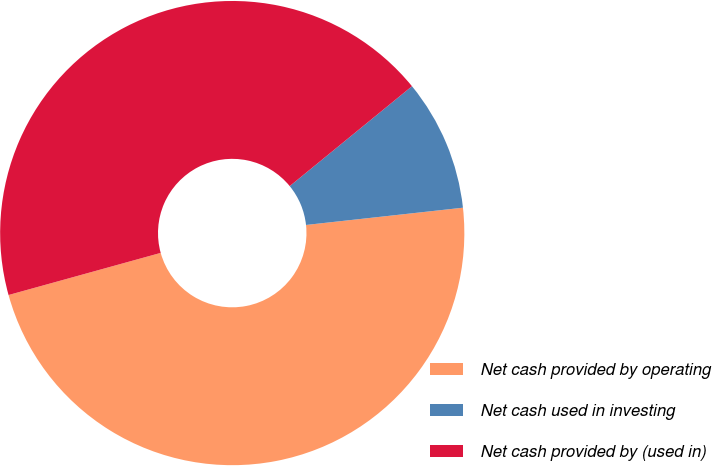Convert chart. <chart><loc_0><loc_0><loc_500><loc_500><pie_chart><fcel>Net cash provided by operating<fcel>Net cash used in investing<fcel>Net cash provided by (used in)<nl><fcel>47.45%<fcel>9.16%<fcel>43.4%<nl></chart> 